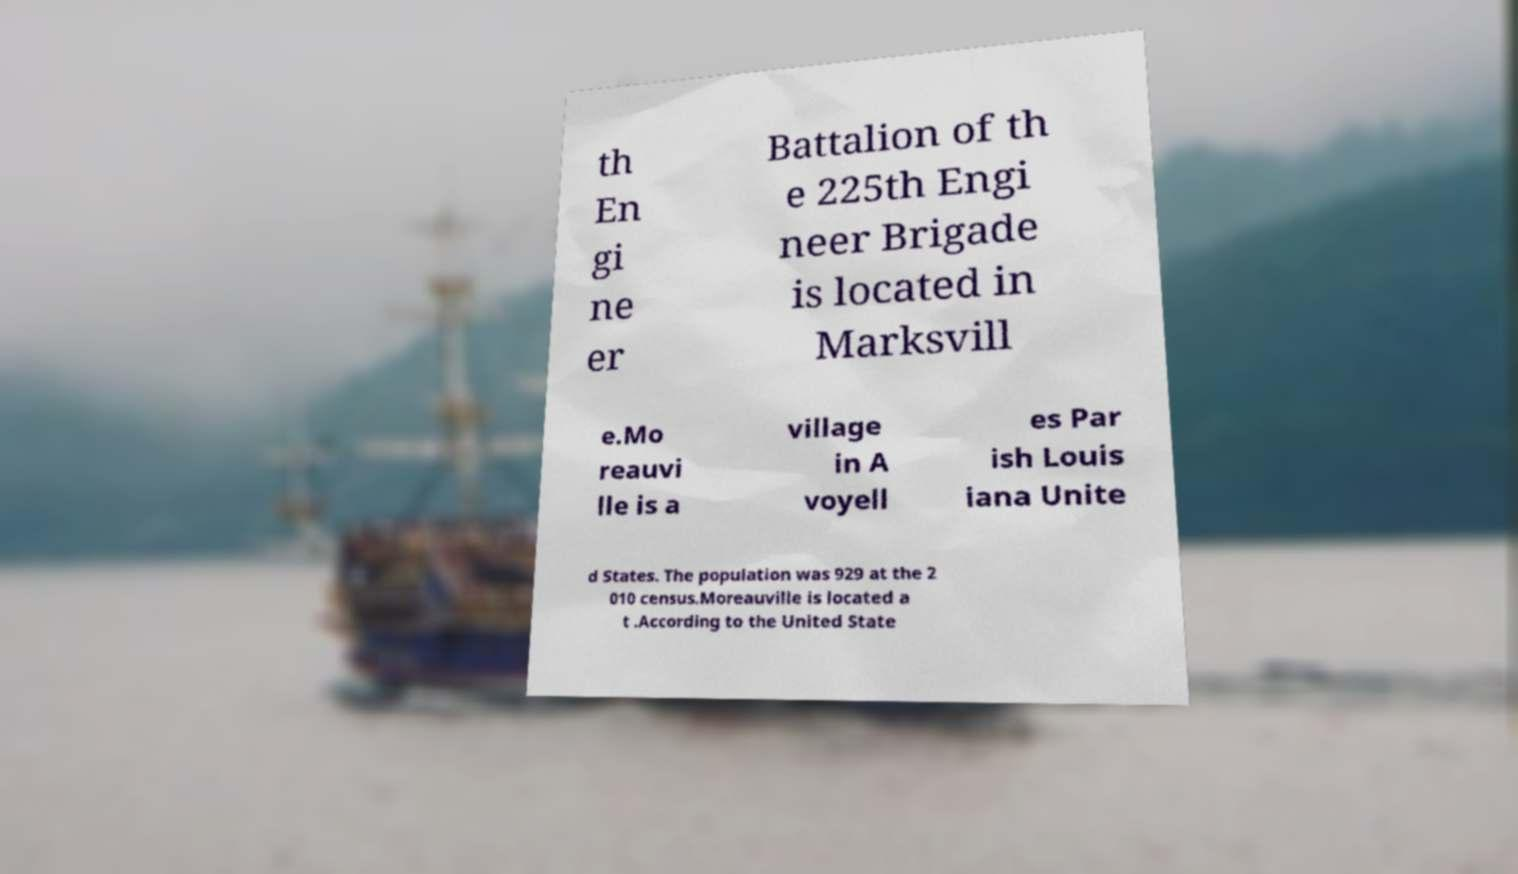I need the written content from this picture converted into text. Can you do that? th En gi ne er Battalion of th e 225th Engi neer Brigade is located in Marksvill e.Mo reauvi lle is a village in A voyell es Par ish Louis iana Unite d States. The population was 929 at the 2 010 census.Moreauville is located a t .According to the United State 